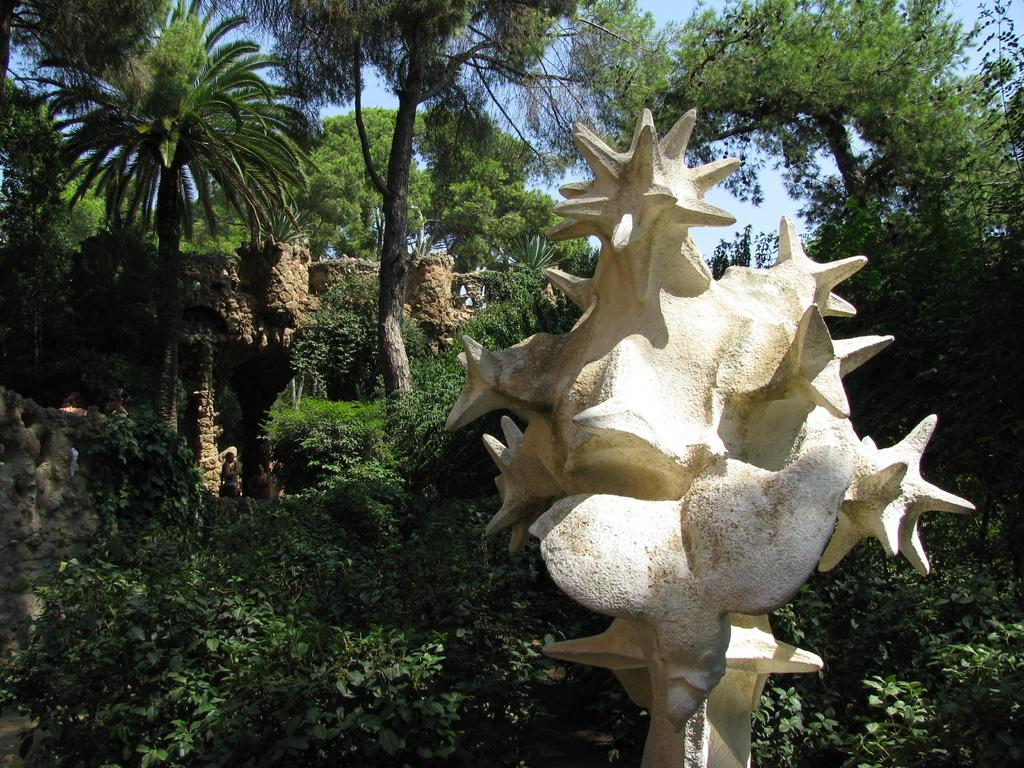What is the main subject of the image? There is a cream color statue in the image. What can be seen in the background of the image? There are plants, a rock structure, and many trees in the background of the image. What is the color of the sky in the image? The sky is blue in the image. What type of soda is being poured over the statue in the image? There is no soda being poured over the statue in the image; it is a cream color statue with no liquid present. What is covering the statue in the image? There is no cover or anything obstructing the statue in the image; it is fully visible. 